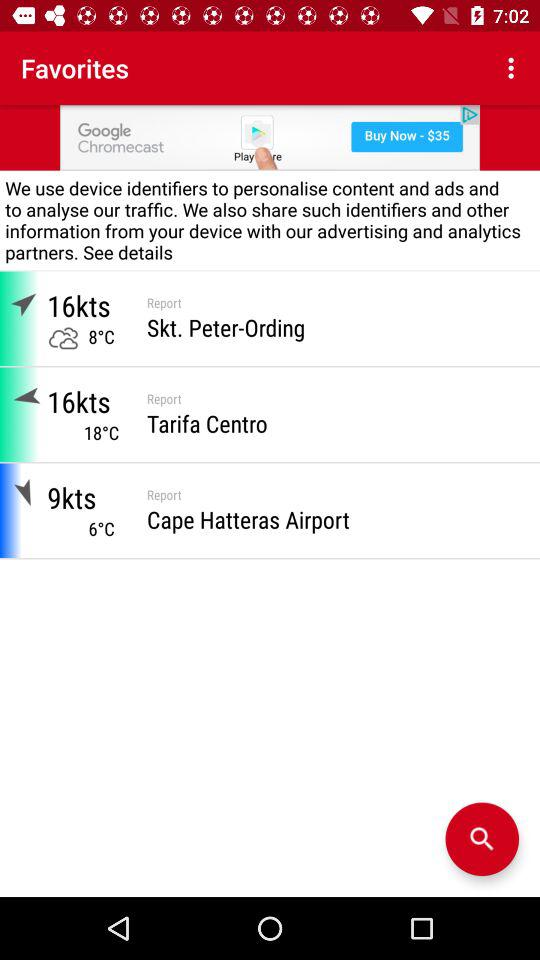What is the temperature in Skt. Peter-Ording? The temperature in Skt. Peter-Ording is 8 °C. 